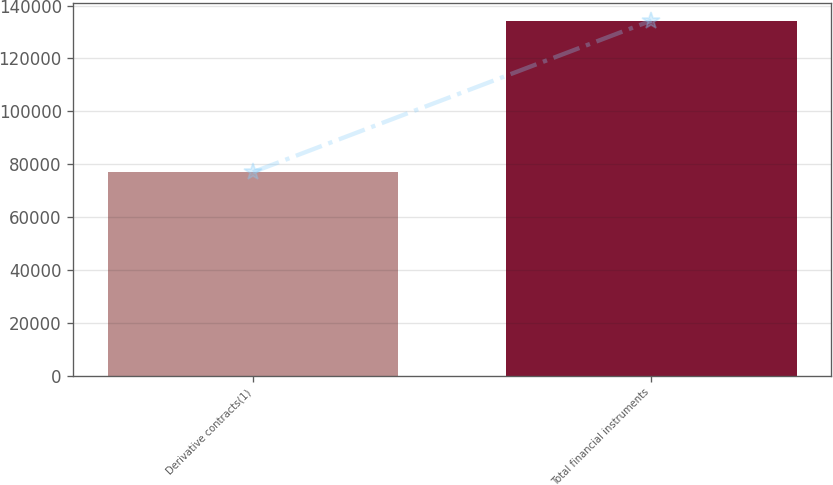<chart> <loc_0><loc_0><loc_500><loc_500><bar_chart><fcel>Derivative contracts(1)<fcel>Total financial instruments<nl><fcel>77003<fcel>134341<nl></chart> 